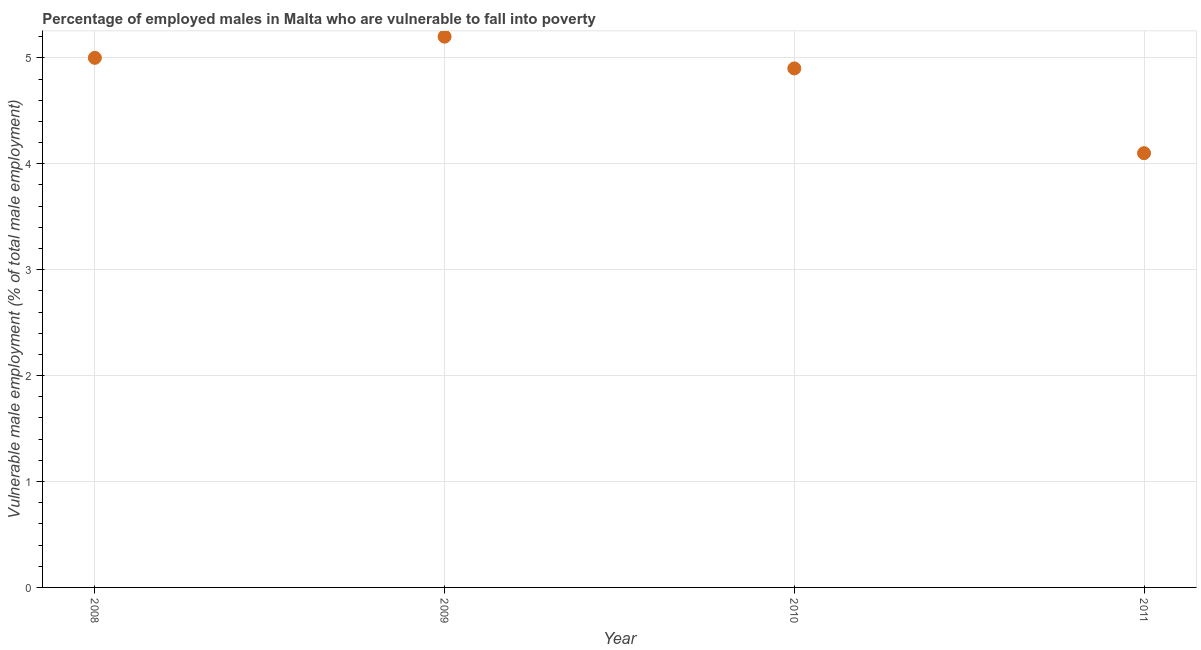What is the percentage of employed males who are vulnerable to fall into poverty in 2008?
Your response must be concise. 5. Across all years, what is the maximum percentage of employed males who are vulnerable to fall into poverty?
Provide a short and direct response. 5.2. Across all years, what is the minimum percentage of employed males who are vulnerable to fall into poverty?
Ensure brevity in your answer.  4.1. In which year was the percentage of employed males who are vulnerable to fall into poverty maximum?
Your response must be concise. 2009. What is the sum of the percentage of employed males who are vulnerable to fall into poverty?
Offer a terse response. 19.2. What is the difference between the percentage of employed males who are vulnerable to fall into poverty in 2008 and 2009?
Offer a very short reply. -0.2. What is the average percentage of employed males who are vulnerable to fall into poverty per year?
Provide a succinct answer. 4.8. What is the median percentage of employed males who are vulnerable to fall into poverty?
Offer a very short reply. 4.95. What is the ratio of the percentage of employed males who are vulnerable to fall into poverty in 2008 to that in 2009?
Your answer should be compact. 0.96. What is the difference between the highest and the second highest percentage of employed males who are vulnerable to fall into poverty?
Your answer should be compact. 0.2. What is the difference between the highest and the lowest percentage of employed males who are vulnerable to fall into poverty?
Your answer should be very brief. 1.1. In how many years, is the percentage of employed males who are vulnerable to fall into poverty greater than the average percentage of employed males who are vulnerable to fall into poverty taken over all years?
Your answer should be very brief. 3. Are the values on the major ticks of Y-axis written in scientific E-notation?
Your response must be concise. No. Does the graph contain any zero values?
Give a very brief answer. No. Does the graph contain grids?
Offer a very short reply. Yes. What is the title of the graph?
Give a very brief answer. Percentage of employed males in Malta who are vulnerable to fall into poverty. What is the label or title of the X-axis?
Make the answer very short. Year. What is the label or title of the Y-axis?
Provide a short and direct response. Vulnerable male employment (% of total male employment). What is the Vulnerable male employment (% of total male employment) in 2009?
Make the answer very short. 5.2. What is the Vulnerable male employment (% of total male employment) in 2010?
Keep it short and to the point. 4.9. What is the Vulnerable male employment (% of total male employment) in 2011?
Offer a very short reply. 4.1. What is the difference between the Vulnerable male employment (% of total male employment) in 2009 and 2010?
Your answer should be compact. 0.3. What is the difference between the Vulnerable male employment (% of total male employment) in 2009 and 2011?
Your answer should be very brief. 1.1. What is the ratio of the Vulnerable male employment (% of total male employment) in 2008 to that in 2009?
Your answer should be compact. 0.96. What is the ratio of the Vulnerable male employment (% of total male employment) in 2008 to that in 2011?
Your answer should be compact. 1.22. What is the ratio of the Vulnerable male employment (% of total male employment) in 2009 to that in 2010?
Give a very brief answer. 1.06. What is the ratio of the Vulnerable male employment (% of total male employment) in 2009 to that in 2011?
Your response must be concise. 1.27. What is the ratio of the Vulnerable male employment (% of total male employment) in 2010 to that in 2011?
Ensure brevity in your answer.  1.2. 